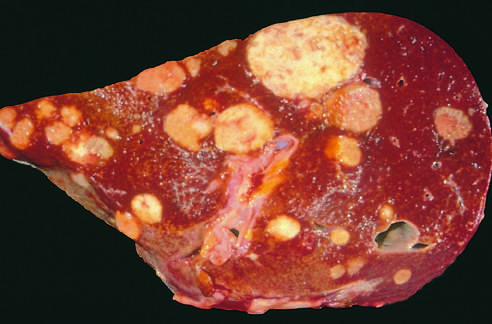what is a liver studded with?
Answer the question using a single word or phrase. Metastatic cancer 